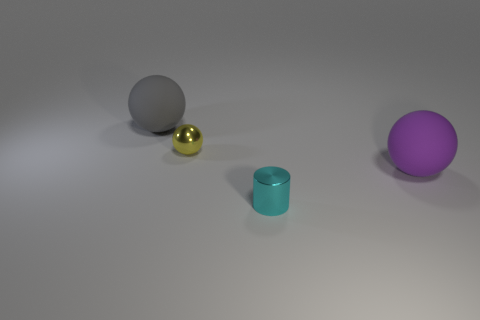Add 1 large rubber spheres. How many objects exist? 5 Subtract all spheres. How many objects are left? 1 Add 2 cyan metal cylinders. How many cyan metal cylinders are left? 3 Add 2 tiny brown metallic blocks. How many tiny brown metallic blocks exist? 2 Subtract 0 purple cubes. How many objects are left? 4 Subtract all big gray matte balls. Subtract all small yellow things. How many objects are left? 2 